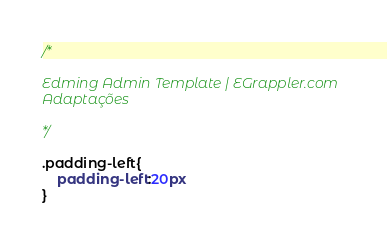Convert code to text. <code><loc_0><loc_0><loc_500><loc_500><_CSS_>/*

Edming Admin Template | EGrappler.com
Adaptações

*/

.padding-left{
    padding-left:20px
}</code> 